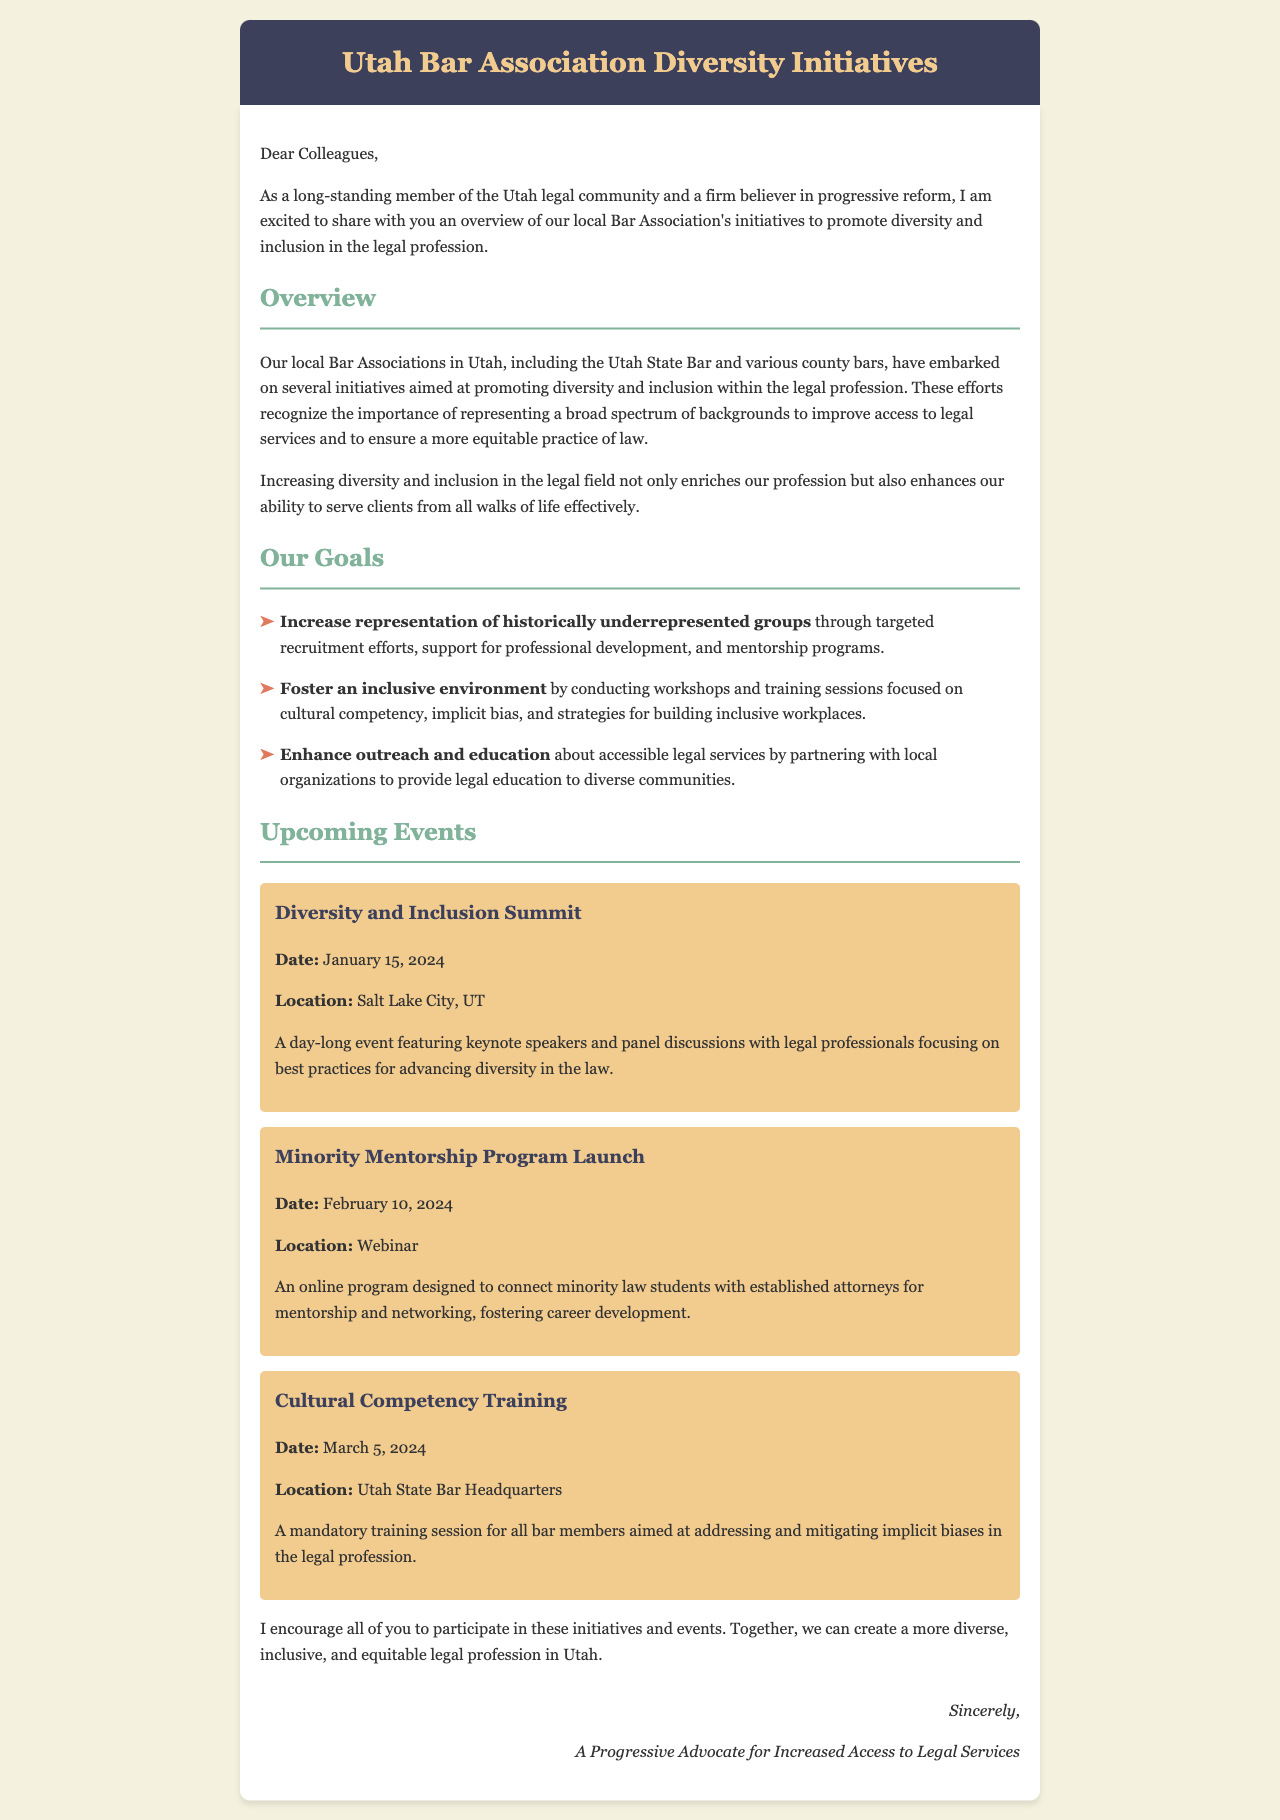What is the date of the Diversity and Inclusion Summit? The document specifies that the Diversity and Inclusion Summit will take place on January 15, 2024.
Answer: January 15, 2024 What is the location of the Minority Mentorship Program Launch? According to the document, the Minority Mentorship Program Launch will be held as a webinar.
Answer: Webinar What is one of the goals related to recruitment? The document outlines a goal to increase representation of historically underrepresented groups through targeted recruitment efforts.
Answer: Targeted recruitment efforts What type of training is mentioned for all bar members? The document states that there is a mandatory training session on cultural competency for all bar members.
Answer: Cultural competency training How many events are listed in the document? The document includes three upcoming events under the section titled "Upcoming Events."
Answer: Three What type of environment does the Bar Association aim to foster? The document mentions fostering an inclusive environment by conducting workshops and training sessions.
Answer: Inclusive environment What is the overarching purpose of the initiatives outlined in the document? The overall purpose of the initiatives is to promote diversity and inclusion within the legal profession.
Answer: Promote diversity and inclusion What is the color of the header background in the document? The header background color specified in the document is #3d405b.
Answer: #3d405b 